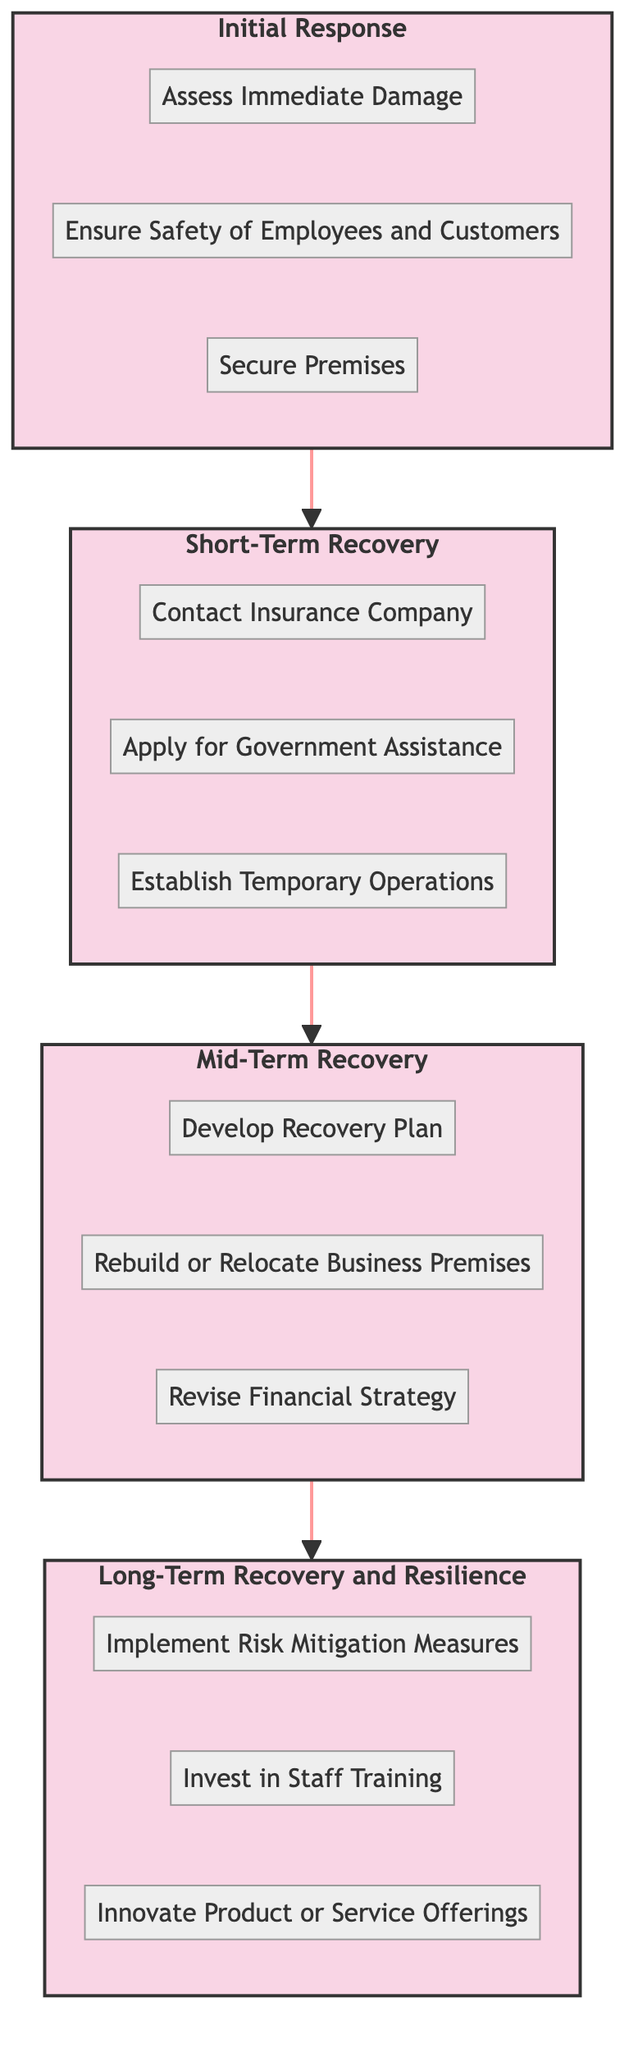What is the highest stage in the decision-making timeline? The diagram clearly shows the flow of stages from bottom to top, with "Long-Term Recovery and Resilience" positioned at the top, indicating it is the highest stage.
Answer: Long-Term Recovery and Resilience How many stages are shown in the diagram? By counting the defined stages in the diagram, we see four distinct stages: Initial Response, Short-Term Recovery, Mid-Term Recovery, and Long-Term Recovery and Resilience, leading to a total of four stages.
Answer: 4 Which stage comes immediately after Short-Term Recovery? Analyzing the flow, we can see that Short-Term Recovery leads directly to Mid-Term Recovery as the next step in the decision-making process.
Answer: Mid-Term Recovery List one action that must be taken in the Initial Response stage. The Initial Response stage is expanded to show three key actions, one of which is "Assess Immediate Damage." This represents an essential step in the immediate aftermath of a disaster.
Answer: Assess Immediate Damage What is the last action listed in the Long-Term Recovery and Resilience stage? The Long-Term Recovery and Resilience stage includes three actions, with "Innovate Product or Service Offerings" being the final action detailed in this stage, indicating it as the culminating step in recovery efforts.
Answer: Innovate Product or Service Offerings What is the first action in the Mid-Term Recovery stage? By looking at the Mid-Term Recovery stage, we can see it starts with "Develop Recovery Plan," which is the first action indicated in this stage.
Answer: Develop Recovery Plan How many actions are included in the Short-Term Recovery stage? The Short-Term Recovery stage contains three actions: "Contact Insurance Company," "Apply for Government Assistance," and "Establish Temporary Operations," resulting in a total of three actions in this stage.
Answer: 3 What is the relationship between the stages of recovery? The stages are organized sequentially from bottom to top, meaning each stage leads to the next higher stage, indicating a logical progression in recovery efforts.
Answer: Sequential progression 